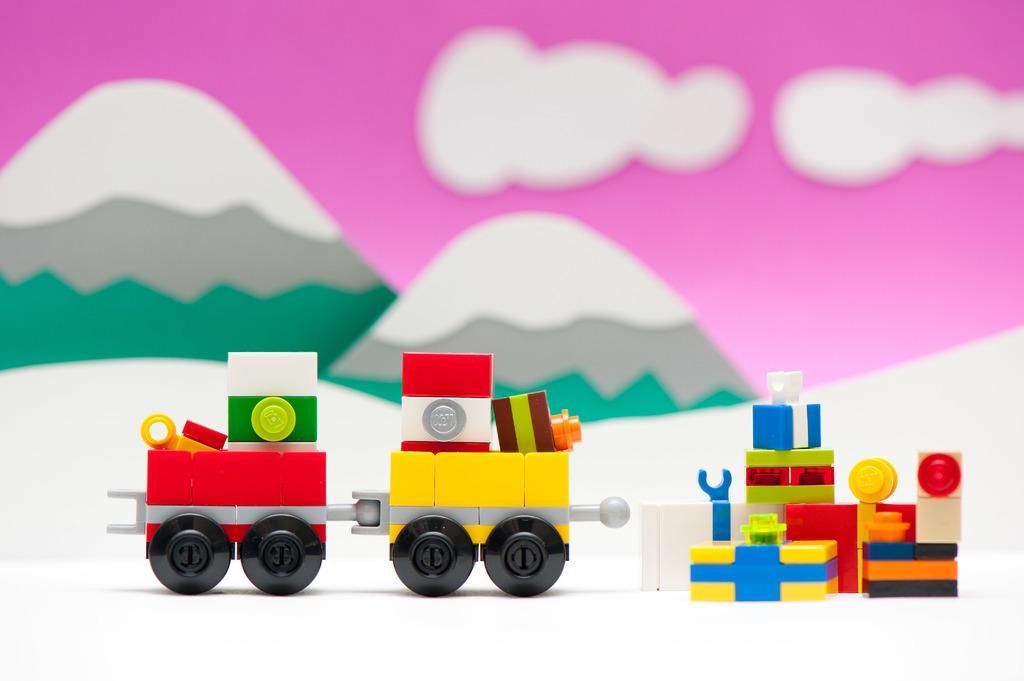Could you give a brief overview of what you see in this image? In this image there is a small train which is made up of lego toys. In the background there are mountains which are made up of cardboard. 